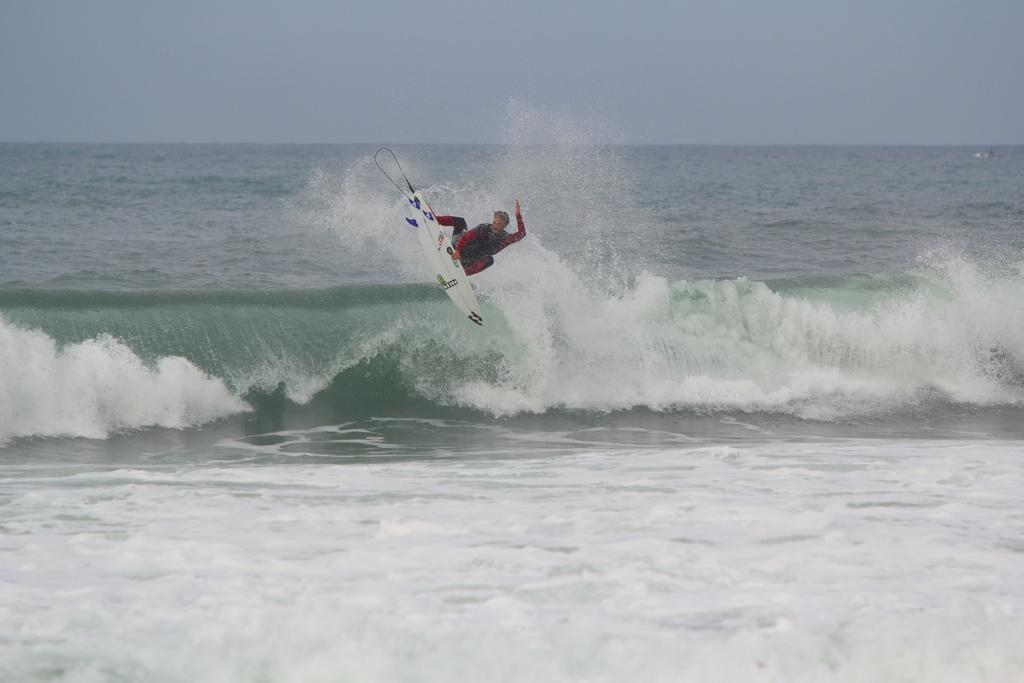What is the main subject of the image? The main subject of the image is a man. What is the man doing in the image? The man is surfing on water in the image. What type of chin can be seen on the man in the image? There is no chin visible on the man in the image, as it is not possible to see a person's chin while they are surfing on water. 